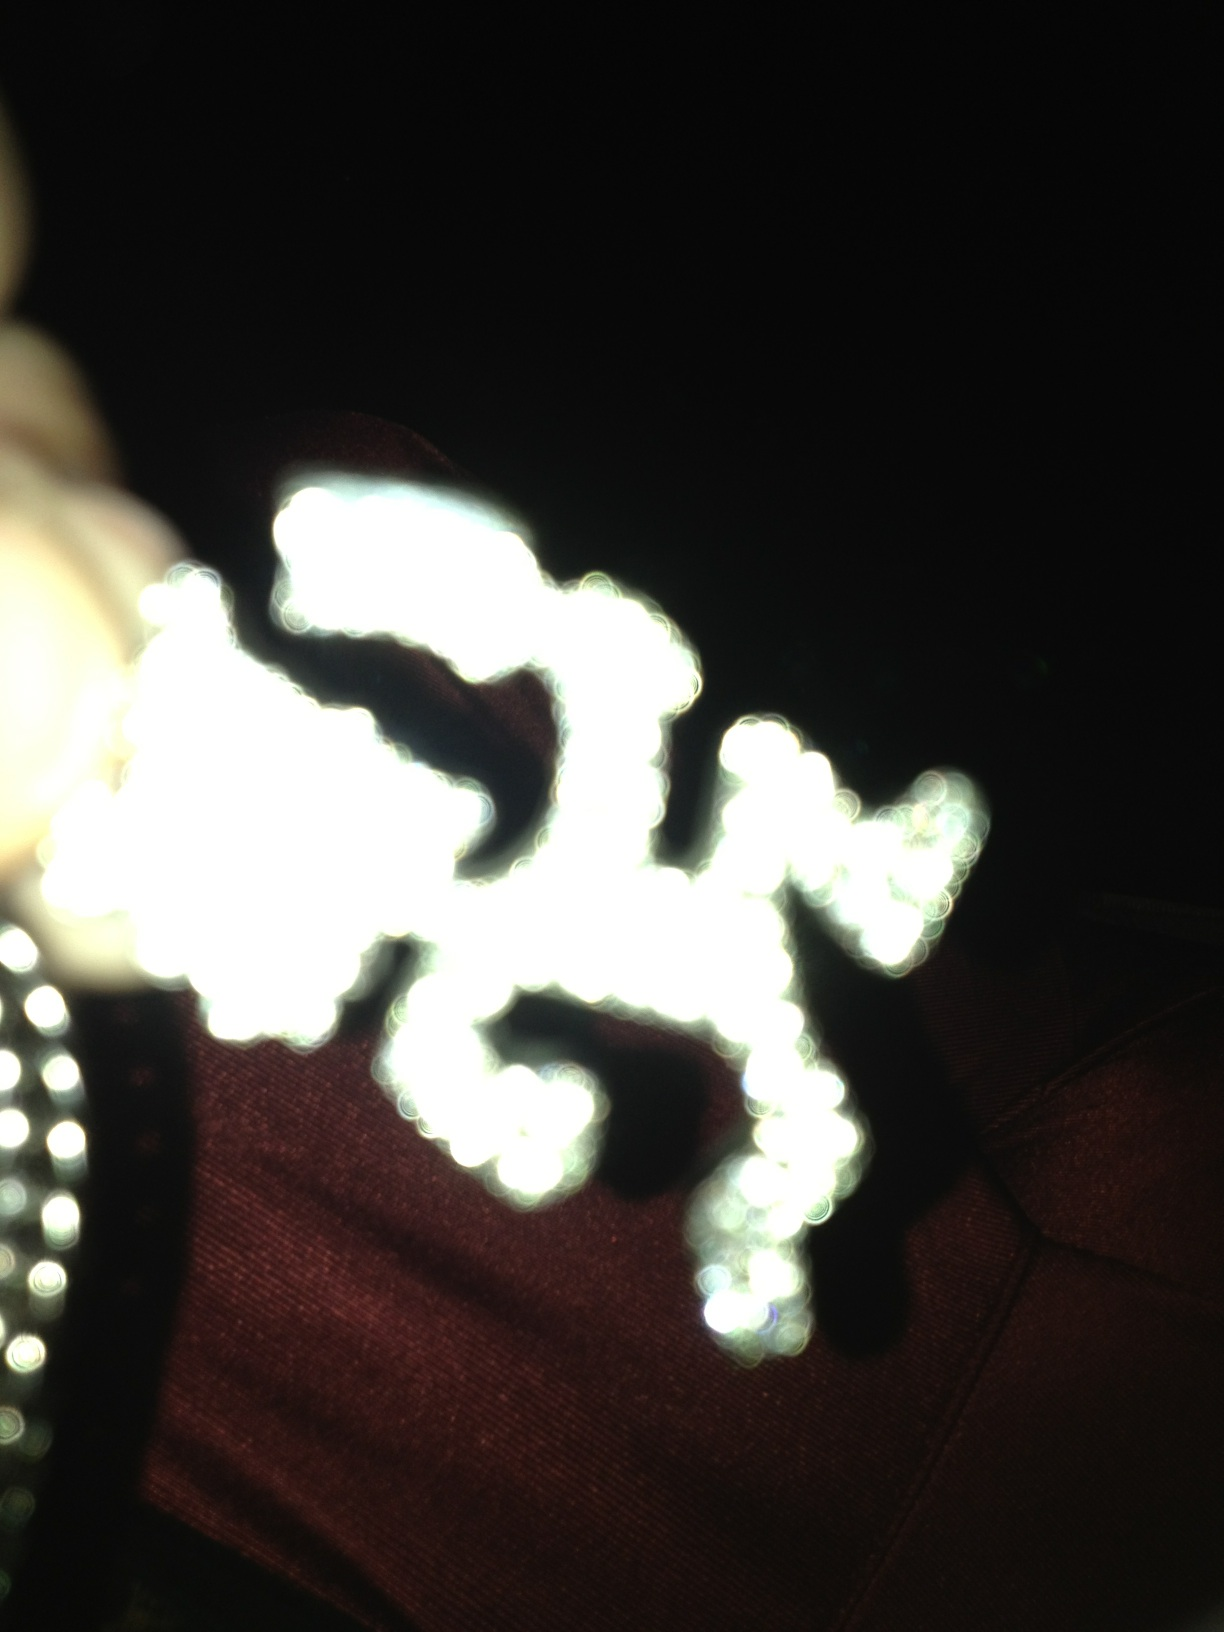What might this blurred object represent or symbolize? Given the blurred quality and the glimpses of sparkling lights or reflections, this object might symbolize brightness, mystery, or celebration. These interpretations are speculative and could vary widely depending on cultural context and personal perception. 